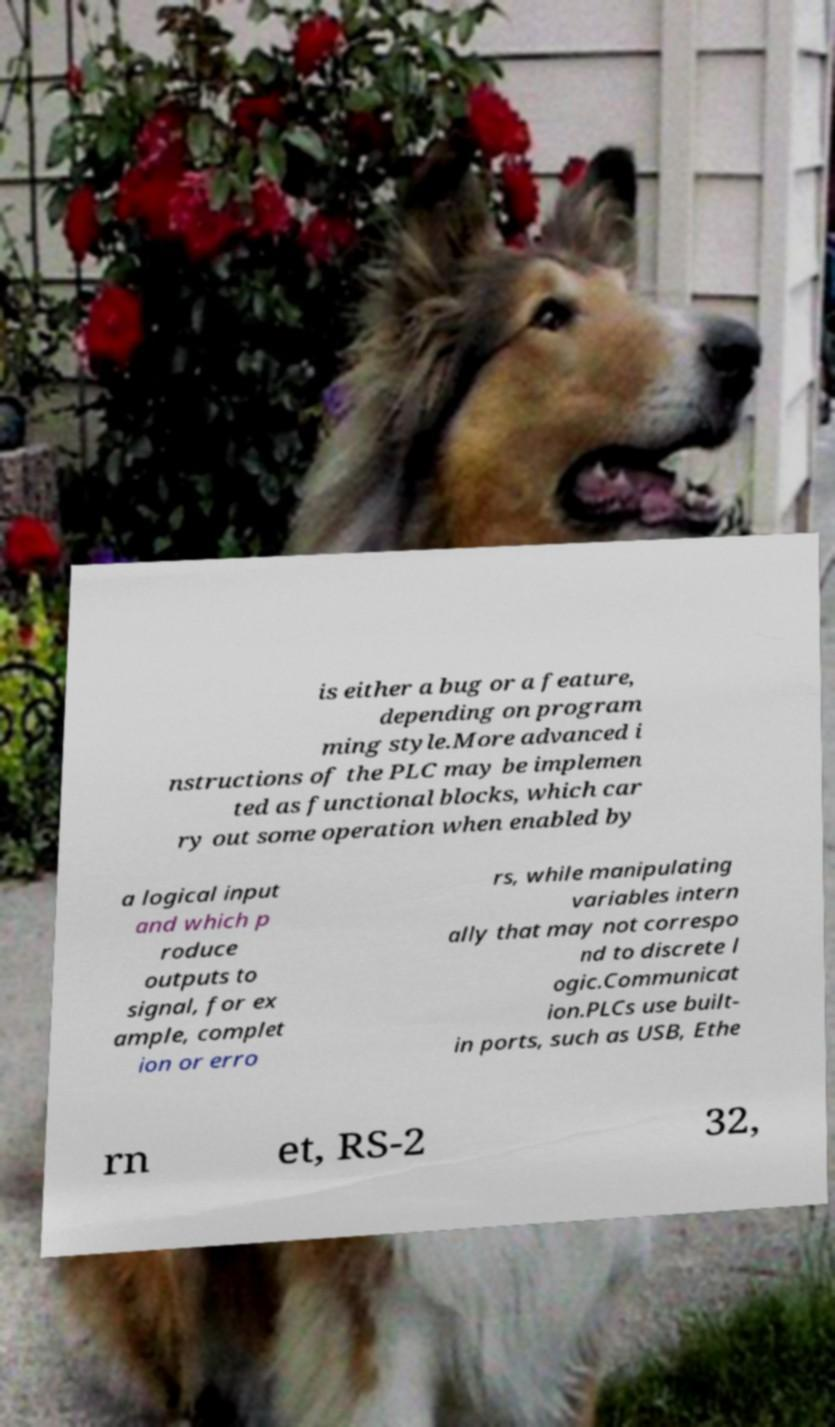Please identify and transcribe the text found in this image. is either a bug or a feature, depending on program ming style.More advanced i nstructions of the PLC may be implemen ted as functional blocks, which car ry out some operation when enabled by a logical input and which p roduce outputs to signal, for ex ample, complet ion or erro rs, while manipulating variables intern ally that may not correspo nd to discrete l ogic.Communicat ion.PLCs use built- in ports, such as USB, Ethe rn et, RS-2 32, 